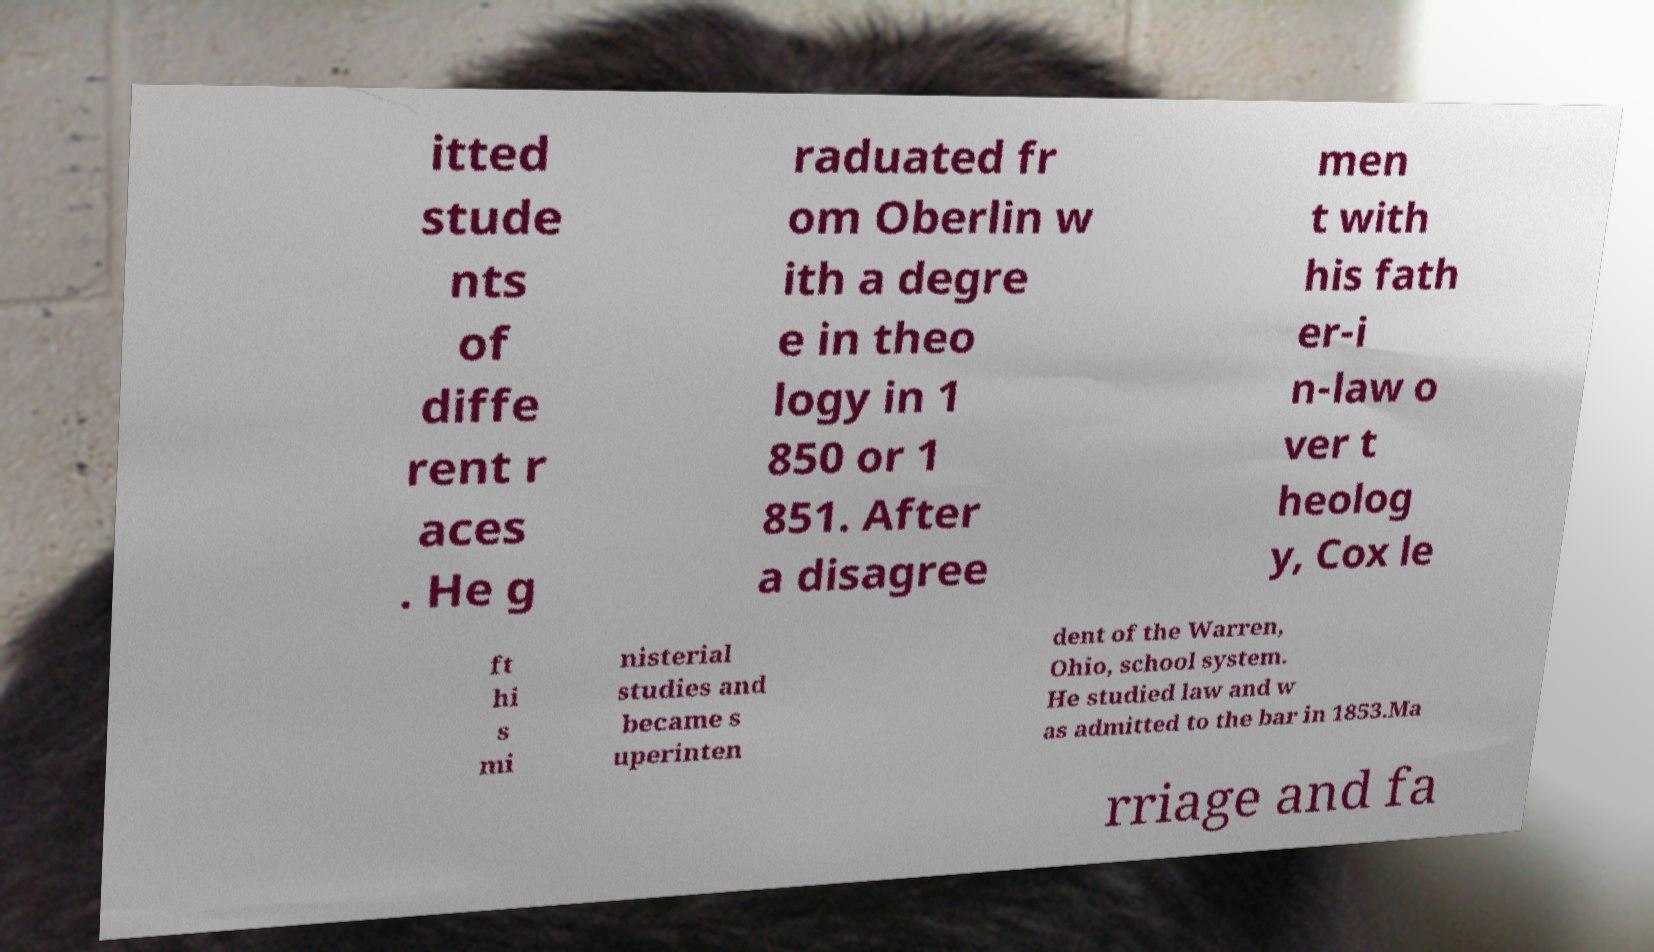Can you accurately transcribe the text from the provided image for me? itted stude nts of diffe rent r aces . He g raduated fr om Oberlin w ith a degre e in theo logy in 1 850 or 1 851. After a disagree men t with his fath er-i n-law o ver t heolog y, Cox le ft hi s mi nisterial studies and became s uperinten dent of the Warren, Ohio, school system. He studied law and w as admitted to the bar in 1853.Ma rriage and fa 